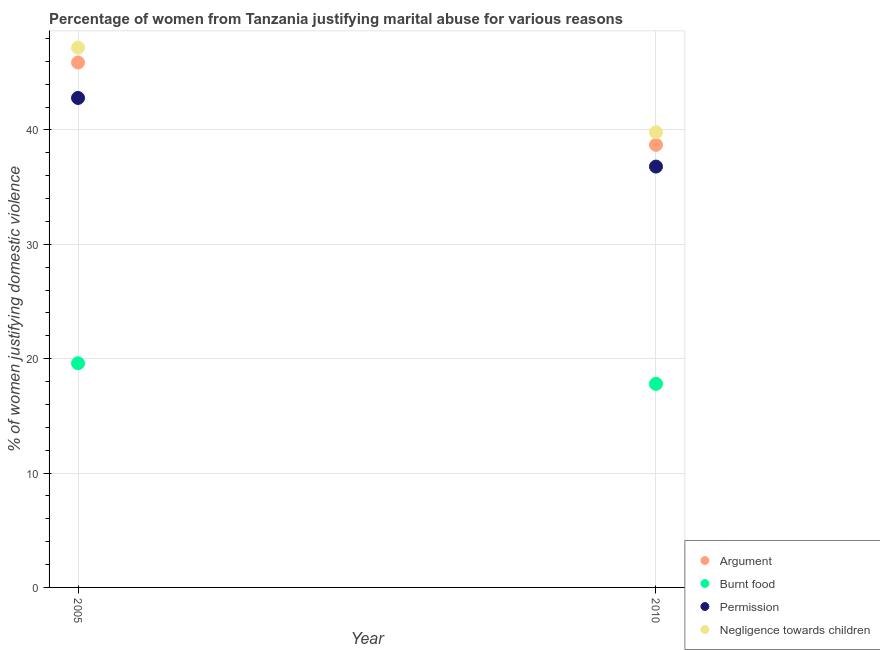Is the number of dotlines equal to the number of legend labels?
Give a very brief answer. Yes. What is the percentage of women justifying abuse for burning food in 2005?
Provide a short and direct response. 19.6. Across all years, what is the maximum percentage of women justifying abuse for showing negligence towards children?
Make the answer very short. 47.2. Across all years, what is the minimum percentage of women justifying abuse for showing negligence towards children?
Offer a very short reply. 39.8. In which year was the percentage of women justifying abuse for going without permission maximum?
Your answer should be compact. 2005. What is the total percentage of women justifying abuse for burning food in the graph?
Provide a succinct answer. 37.4. What is the difference between the percentage of women justifying abuse in the case of an argument in 2005 and that in 2010?
Provide a succinct answer. 7.2. What is the difference between the percentage of women justifying abuse for burning food in 2010 and the percentage of women justifying abuse for going without permission in 2005?
Provide a succinct answer. -25. What is the average percentage of women justifying abuse for showing negligence towards children per year?
Offer a very short reply. 43.5. In the year 2010, what is the difference between the percentage of women justifying abuse for burning food and percentage of women justifying abuse in the case of an argument?
Give a very brief answer. -20.9. What is the ratio of the percentage of women justifying abuse for showing negligence towards children in 2005 to that in 2010?
Offer a terse response. 1.19. Is the percentage of women justifying abuse for burning food in 2005 less than that in 2010?
Make the answer very short. No. In how many years, is the percentage of women justifying abuse for showing negligence towards children greater than the average percentage of women justifying abuse for showing negligence towards children taken over all years?
Give a very brief answer. 1. Is it the case that in every year, the sum of the percentage of women justifying abuse for burning food and percentage of women justifying abuse for showing negligence towards children is greater than the sum of percentage of women justifying abuse in the case of an argument and percentage of women justifying abuse for going without permission?
Keep it short and to the point. No. Is it the case that in every year, the sum of the percentage of women justifying abuse in the case of an argument and percentage of women justifying abuse for burning food is greater than the percentage of women justifying abuse for going without permission?
Offer a terse response. Yes. Is the percentage of women justifying abuse in the case of an argument strictly greater than the percentage of women justifying abuse for showing negligence towards children over the years?
Provide a succinct answer. No. How many dotlines are there?
Your response must be concise. 4. What is the difference between two consecutive major ticks on the Y-axis?
Give a very brief answer. 10. Are the values on the major ticks of Y-axis written in scientific E-notation?
Your answer should be compact. No. What is the title of the graph?
Offer a very short reply. Percentage of women from Tanzania justifying marital abuse for various reasons. Does "Ease of arranging shipments" appear as one of the legend labels in the graph?
Give a very brief answer. No. What is the label or title of the Y-axis?
Your response must be concise. % of women justifying domestic violence. What is the % of women justifying domestic violence in Argument in 2005?
Ensure brevity in your answer.  45.9. What is the % of women justifying domestic violence of Burnt food in 2005?
Your answer should be compact. 19.6. What is the % of women justifying domestic violence in Permission in 2005?
Provide a succinct answer. 42.8. What is the % of women justifying domestic violence in Negligence towards children in 2005?
Offer a terse response. 47.2. What is the % of women justifying domestic violence in Argument in 2010?
Your answer should be very brief. 38.7. What is the % of women justifying domestic violence of Burnt food in 2010?
Offer a very short reply. 17.8. What is the % of women justifying domestic violence of Permission in 2010?
Make the answer very short. 36.8. What is the % of women justifying domestic violence in Negligence towards children in 2010?
Ensure brevity in your answer.  39.8. Across all years, what is the maximum % of women justifying domestic violence of Argument?
Offer a terse response. 45.9. Across all years, what is the maximum % of women justifying domestic violence in Burnt food?
Provide a short and direct response. 19.6. Across all years, what is the maximum % of women justifying domestic violence in Permission?
Your answer should be very brief. 42.8. Across all years, what is the maximum % of women justifying domestic violence of Negligence towards children?
Your answer should be compact. 47.2. Across all years, what is the minimum % of women justifying domestic violence in Argument?
Provide a short and direct response. 38.7. Across all years, what is the minimum % of women justifying domestic violence in Permission?
Your answer should be very brief. 36.8. Across all years, what is the minimum % of women justifying domestic violence of Negligence towards children?
Give a very brief answer. 39.8. What is the total % of women justifying domestic violence of Argument in the graph?
Ensure brevity in your answer.  84.6. What is the total % of women justifying domestic violence of Burnt food in the graph?
Offer a very short reply. 37.4. What is the total % of women justifying domestic violence in Permission in the graph?
Your answer should be very brief. 79.6. What is the difference between the % of women justifying domestic violence in Burnt food in 2005 and that in 2010?
Your response must be concise. 1.8. What is the difference between the % of women justifying domestic violence of Argument in 2005 and the % of women justifying domestic violence of Burnt food in 2010?
Your response must be concise. 28.1. What is the difference between the % of women justifying domestic violence of Argument in 2005 and the % of women justifying domestic violence of Negligence towards children in 2010?
Provide a succinct answer. 6.1. What is the difference between the % of women justifying domestic violence of Burnt food in 2005 and the % of women justifying domestic violence of Permission in 2010?
Ensure brevity in your answer.  -17.2. What is the difference between the % of women justifying domestic violence of Burnt food in 2005 and the % of women justifying domestic violence of Negligence towards children in 2010?
Offer a terse response. -20.2. What is the difference between the % of women justifying domestic violence in Permission in 2005 and the % of women justifying domestic violence in Negligence towards children in 2010?
Provide a short and direct response. 3. What is the average % of women justifying domestic violence of Argument per year?
Keep it short and to the point. 42.3. What is the average % of women justifying domestic violence of Burnt food per year?
Your response must be concise. 18.7. What is the average % of women justifying domestic violence in Permission per year?
Ensure brevity in your answer.  39.8. What is the average % of women justifying domestic violence in Negligence towards children per year?
Offer a terse response. 43.5. In the year 2005, what is the difference between the % of women justifying domestic violence in Argument and % of women justifying domestic violence in Burnt food?
Make the answer very short. 26.3. In the year 2005, what is the difference between the % of women justifying domestic violence of Argument and % of women justifying domestic violence of Negligence towards children?
Provide a short and direct response. -1.3. In the year 2005, what is the difference between the % of women justifying domestic violence of Burnt food and % of women justifying domestic violence of Permission?
Your answer should be very brief. -23.2. In the year 2005, what is the difference between the % of women justifying domestic violence in Burnt food and % of women justifying domestic violence in Negligence towards children?
Your response must be concise. -27.6. In the year 2010, what is the difference between the % of women justifying domestic violence in Argument and % of women justifying domestic violence in Burnt food?
Offer a very short reply. 20.9. In the year 2010, what is the difference between the % of women justifying domestic violence of Argument and % of women justifying domestic violence of Permission?
Give a very brief answer. 1.9. In the year 2010, what is the difference between the % of women justifying domestic violence of Burnt food and % of women justifying domestic violence of Negligence towards children?
Make the answer very short. -22. What is the ratio of the % of women justifying domestic violence in Argument in 2005 to that in 2010?
Provide a short and direct response. 1.19. What is the ratio of the % of women justifying domestic violence of Burnt food in 2005 to that in 2010?
Offer a terse response. 1.1. What is the ratio of the % of women justifying domestic violence of Permission in 2005 to that in 2010?
Provide a succinct answer. 1.16. What is the ratio of the % of women justifying domestic violence in Negligence towards children in 2005 to that in 2010?
Offer a very short reply. 1.19. What is the difference between the highest and the second highest % of women justifying domestic violence in Argument?
Your response must be concise. 7.2. What is the difference between the highest and the second highest % of women justifying domestic violence in Burnt food?
Your answer should be very brief. 1.8. What is the difference between the highest and the second highest % of women justifying domestic violence in Permission?
Keep it short and to the point. 6. What is the difference between the highest and the second highest % of women justifying domestic violence of Negligence towards children?
Your answer should be very brief. 7.4. What is the difference between the highest and the lowest % of women justifying domestic violence in Argument?
Give a very brief answer. 7.2. 